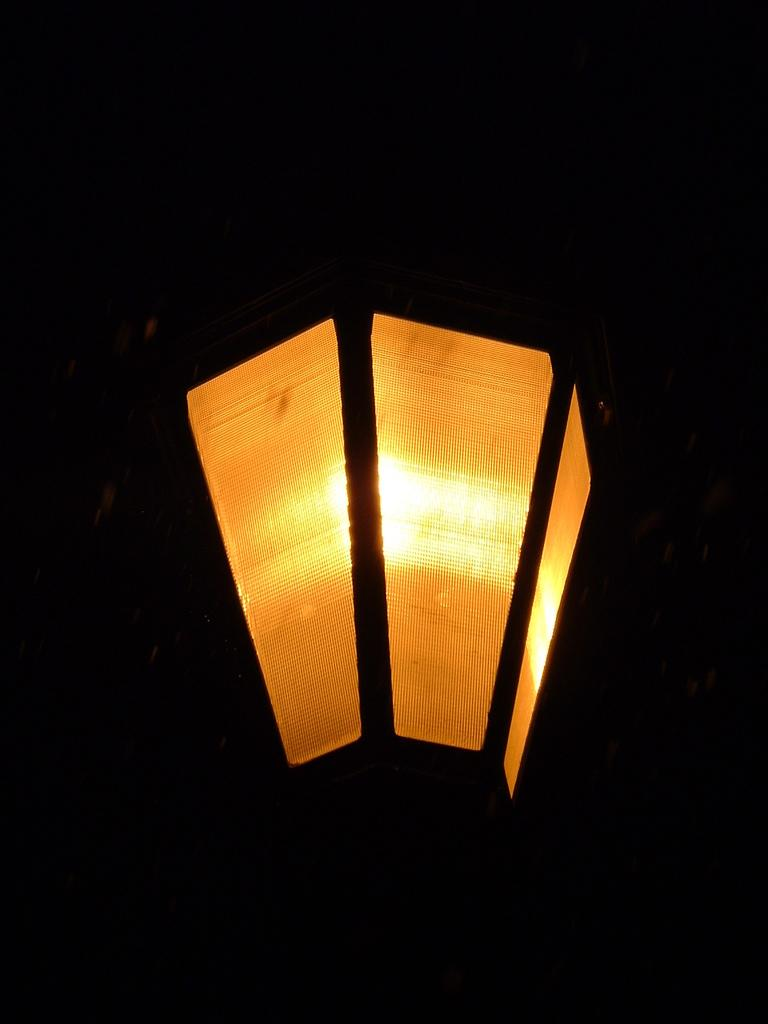What type of object is present in the image that provides illumination? There is a street light in the image that provides illumination. How many rats can be seen climbing on the street light in the image? There are no rats present in the image; it only features a street light. What is the chance of winning a lottery based on the image? The image does not provide any information about lottery chances or winnings. 